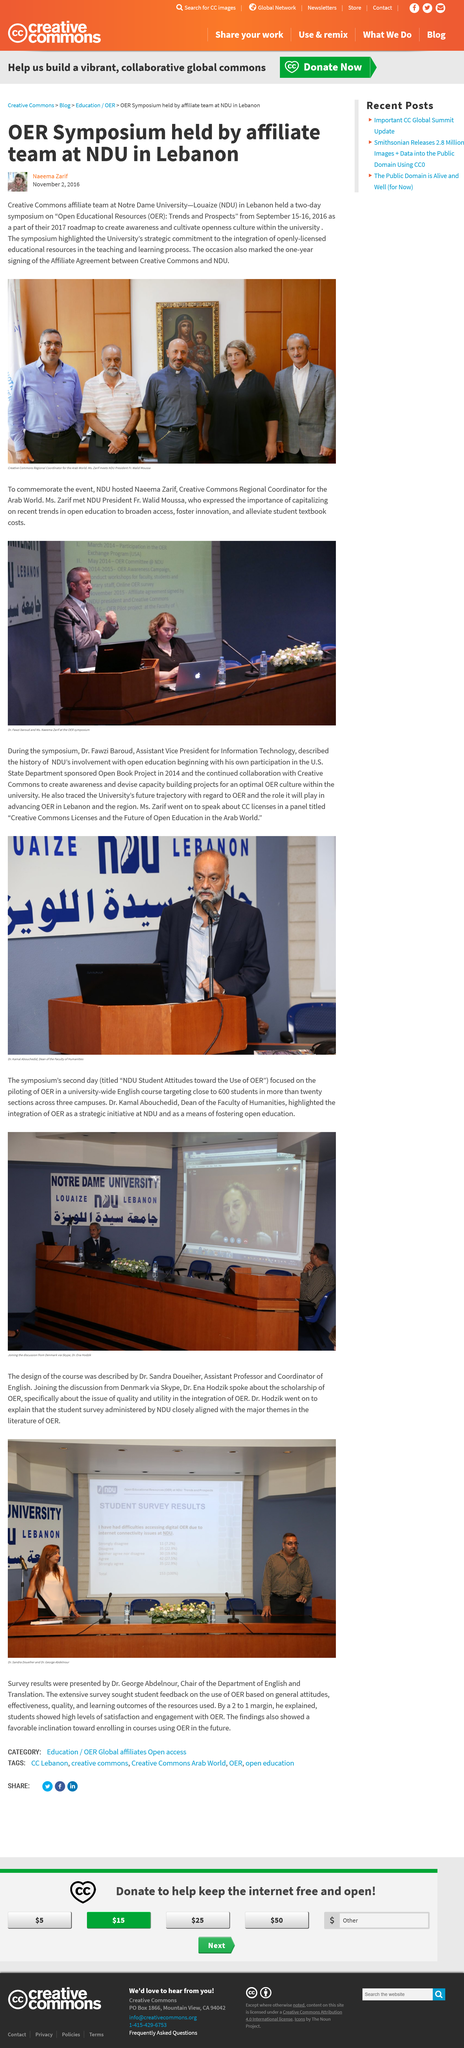Identify some key points in this picture. The Creative Commons symposium took place from September 15-16, 2016. There are two visible water bottles in the picture. The article was written two months after the symposium took place. Naeema Zarif is the Creative Commons Regional Coordinator for the Arab World. President Fr. Walid Moussa is wearing a grey suit in the picture. 